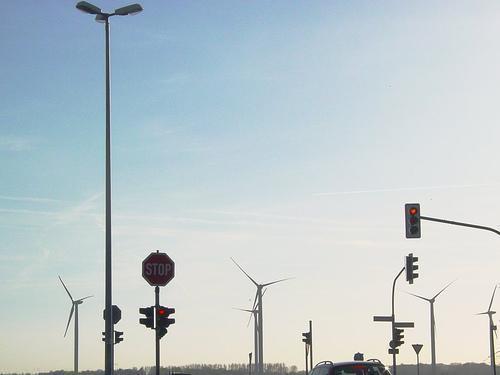The car is operating during which season?
Indicate the correct response and explain using: 'Answer: answer
Rationale: rationale.'
Options: Summer, spring, winter, fall. Answer: winter.
Rationale: The trees in the back look dead. 